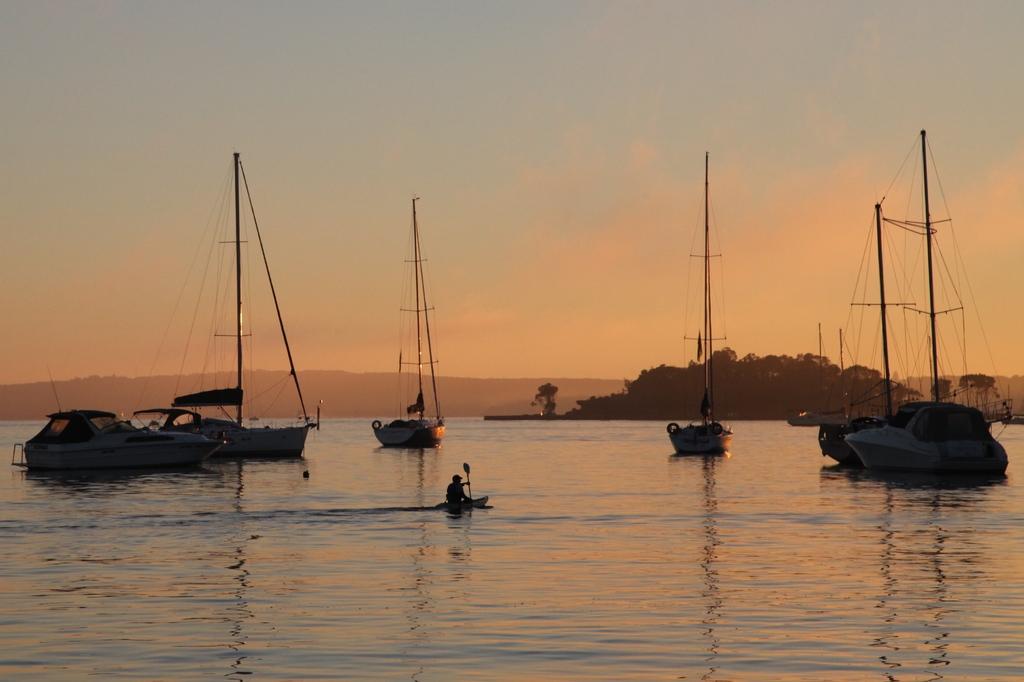Describe this image in one or two sentences. In this image, we can see ships on the water and in there is a person rowing and we can see trees. At the top, there is sky. 